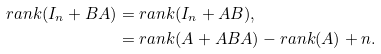Convert formula to latex. <formula><loc_0><loc_0><loc_500><loc_500>r a n k ( I _ { n } + B A ) & = r a n k ( I _ { n } + A B ) , \\ & = r a n k ( A + A B A ) - r a n k ( A ) + n .</formula> 